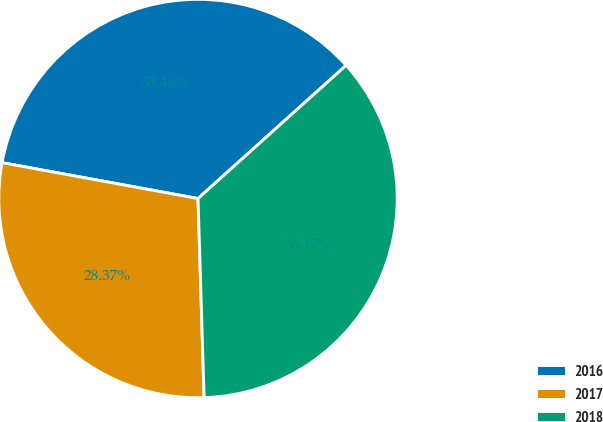Convert chart to OTSL. <chart><loc_0><loc_0><loc_500><loc_500><pie_chart><fcel>2016<fcel>2017<fcel>2018<nl><fcel>35.46%<fcel>28.37%<fcel>36.17%<nl></chart> 